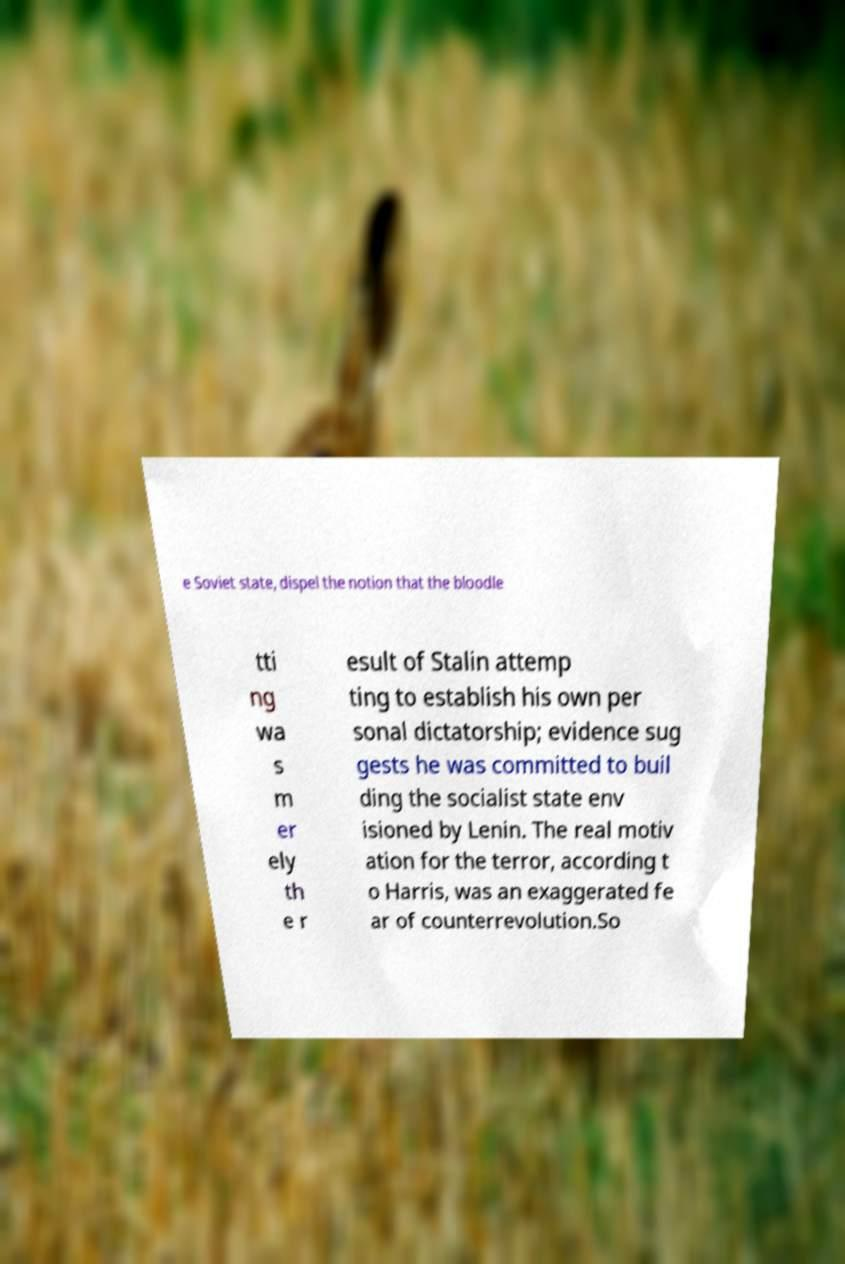Can you accurately transcribe the text from the provided image for me? e Soviet state, dispel the notion that the bloodle tti ng wa s m er ely th e r esult of Stalin attemp ting to establish his own per sonal dictatorship; evidence sug gests he was committed to buil ding the socialist state env isioned by Lenin. The real motiv ation for the terror, according t o Harris, was an exaggerated fe ar of counterrevolution.So 